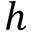<formula> <loc_0><loc_0><loc_500><loc_500>h</formula> 